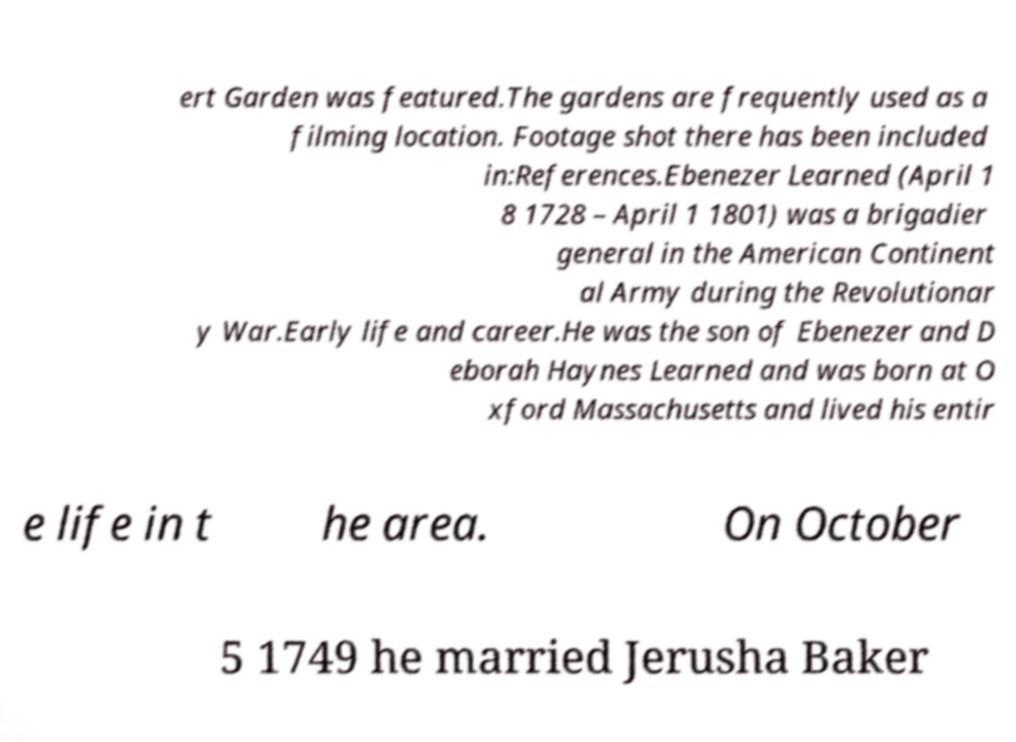I need the written content from this picture converted into text. Can you do that? ert Garden was featured.The gardens are frequently used as a filming location. Footage shot there has been included in:References.Ebenezer Learned (April 1 8 1728 – April 1 1801) was a brigadier general in the American Continent al Army during the Revolutionar y War.Early life and career.He was the son of Ebenezer and D eborah Haynes Learned and was born at O xford Massachusetts and lived his entir e life in t he area. On October 5 1749 he married Jerusha Baker 